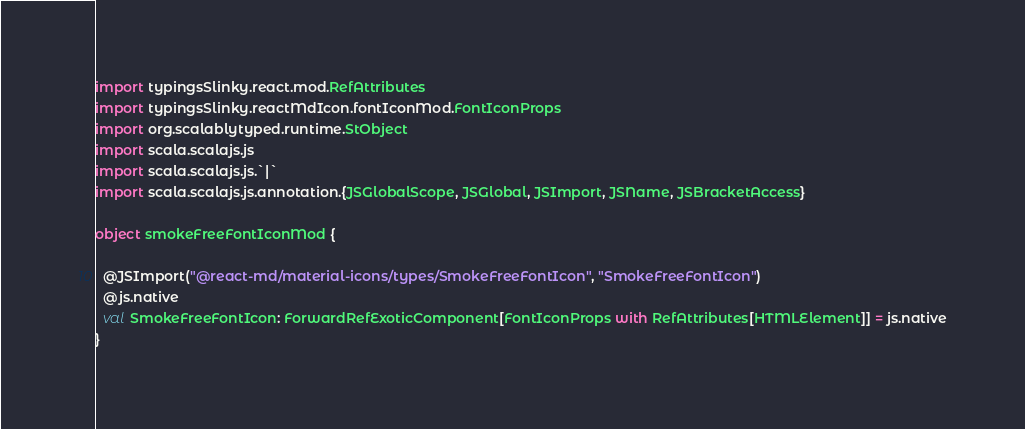Convert code to text. <code><loc_0><loc_0><loc_500><loc_500><_Scala_>import typingsSlinky.react.mod.RefAttributes
import typingsSlinky.reactMdIcon.fontIconMod.FontIconProps
import org.scalablytyped.runtime.StObject
import scala.scalajs.js
import scala.scalajs.js.`|`
import scala.scalajs.js.annotation.{JSGlobalScope, JSGlobal, JSImport, JSName, JSBracketAccess}

object smokeFreeFontIconMod {
  
  @JSImport("@react-md/material-icons/types/SmokeFreeFontIcon", "SmokeFreeFontIcon")
  @js.native
  val SmokeFreeFontIcon: ForwardRefExoticComponent[FontIconProps with RefAttributes[HTMLElement]] = js.native
}
</code> 